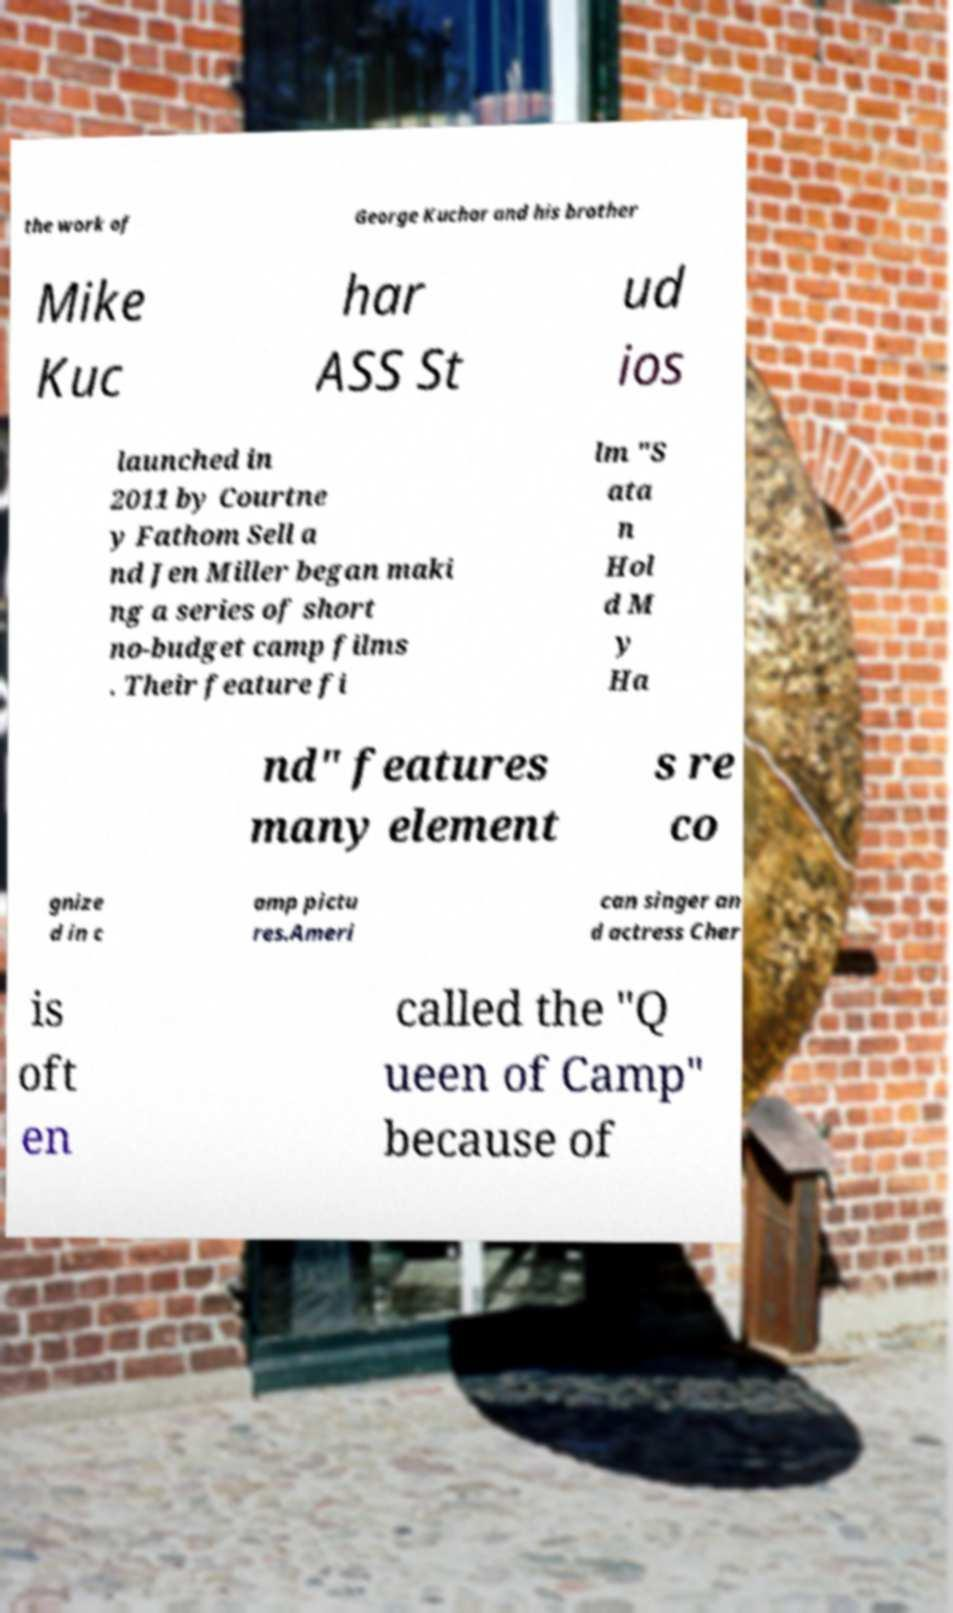For documentation purposes, I need the text within this image transcribed. Could you provide that? the work of George Kuchar and his brother Mike Kuc har ASS St ud ios launched in 2011 by Courtne y Fathom Sell a nd Jen Miller began maki ng a series of short no-budget camp films . Their feature fi lm "S ata n Hol d M y Ha nd" features many element s re co gnize d in c amp pictu res.Ameri can singer an d actress Cher is oft en called the "Q ueen of Camp" because of 